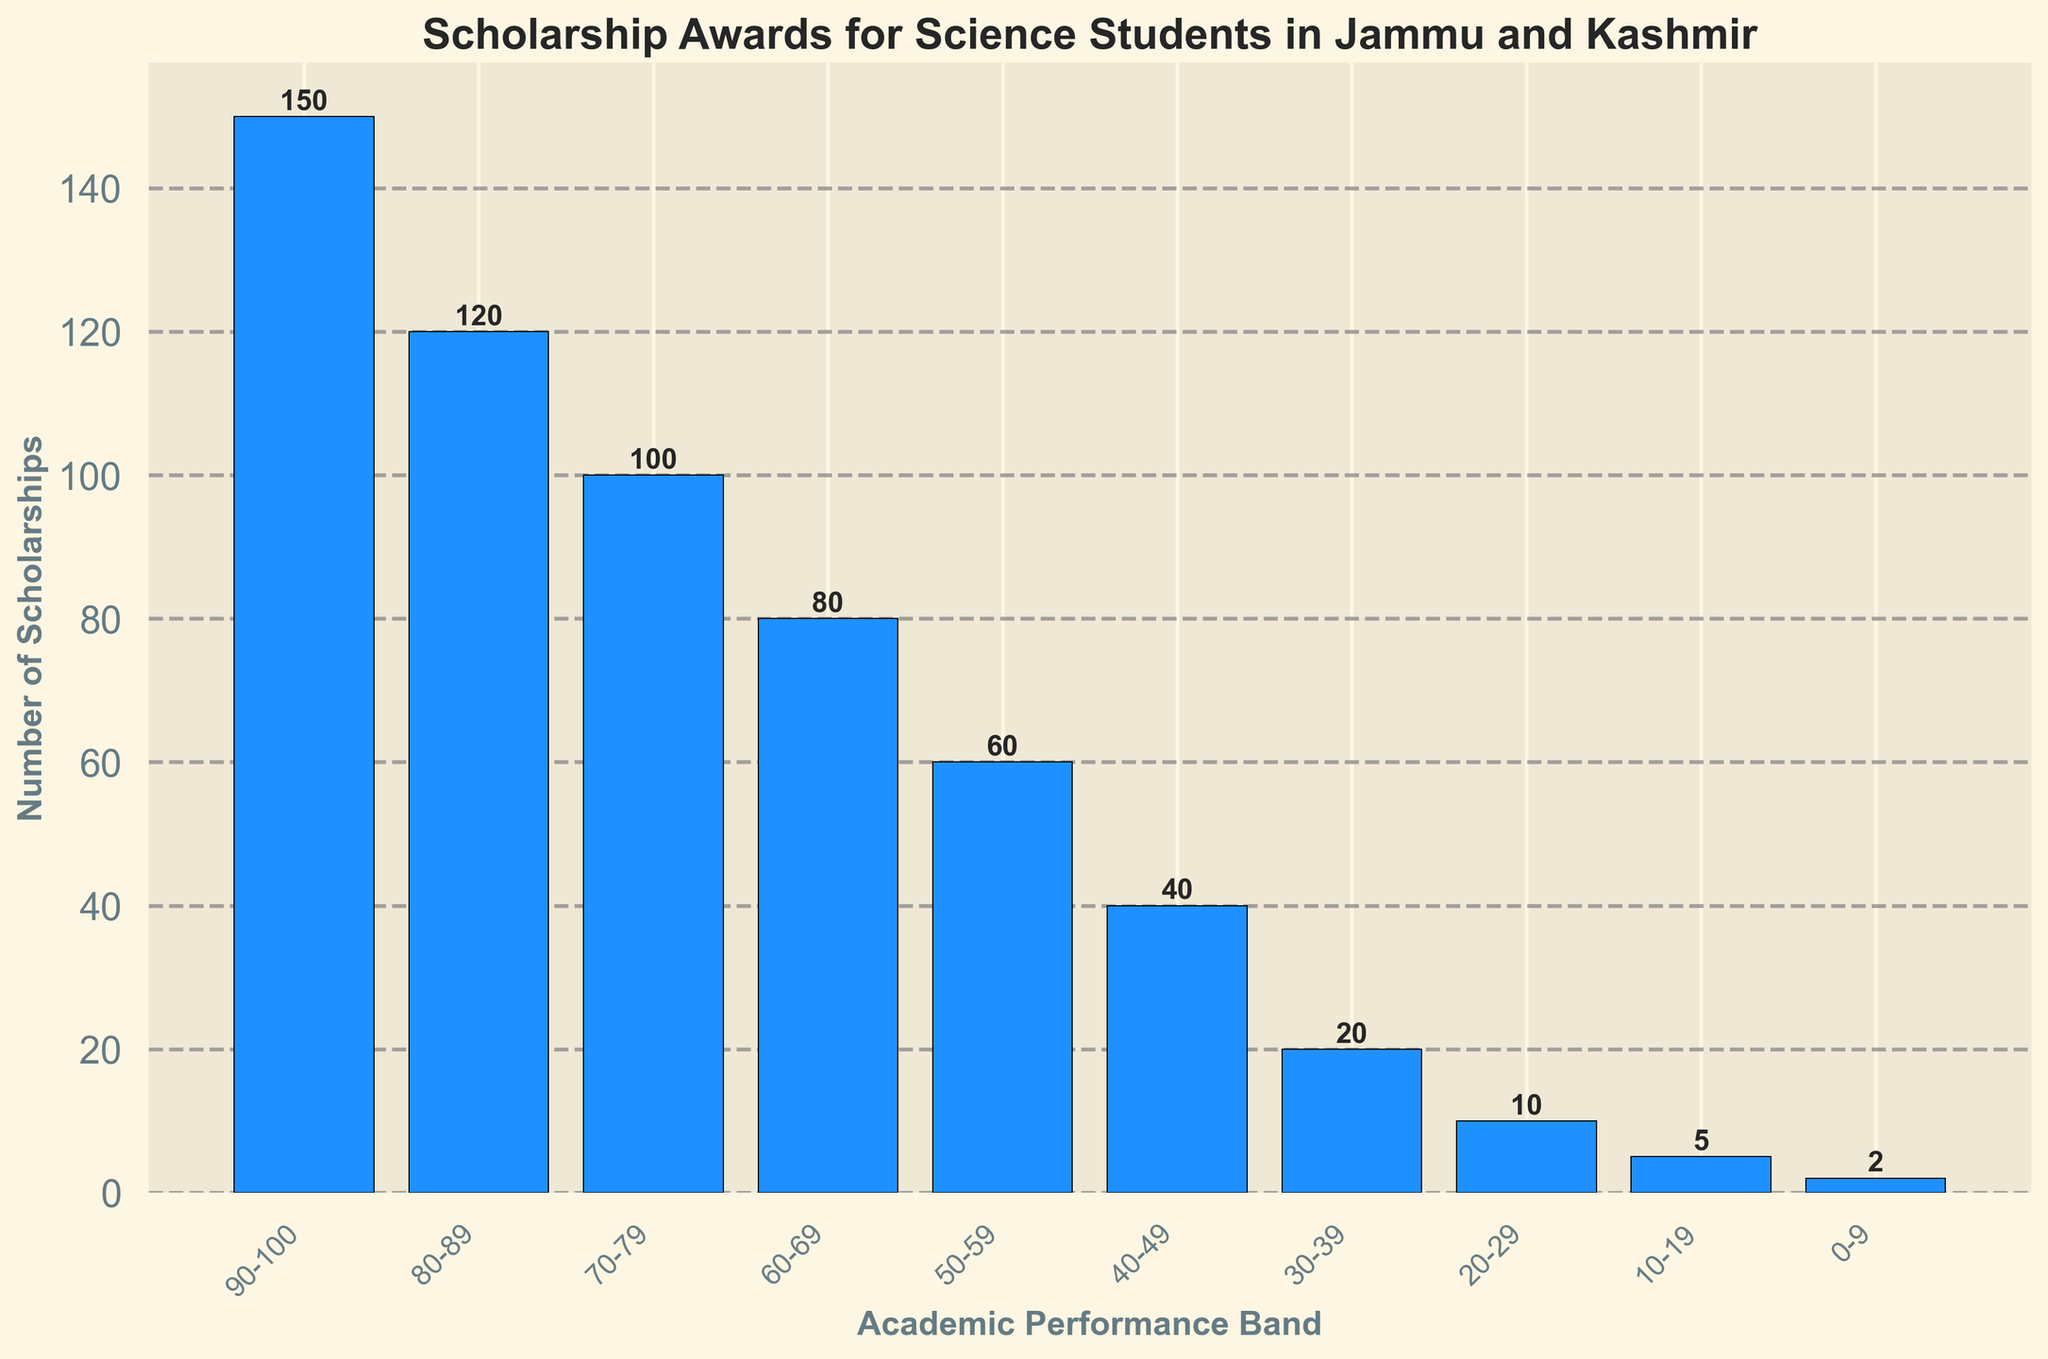What is the academic performance band that receives the highest number of scholarships? The band with the highest bar represents the greatest number of scholarships. Referring to the histogram, the 90-100 performance band shows the highest bar, indicating the highest number of scholarships.
Answer: 90-100 Which academic performance band receives the fewest scholarships? The shortest bar on the histogram indicates the fewest scholarships awarded. The 0-9 performance band has the shortest bar.
Answer: 0-9 How many more scholarships are awarded to students in the 90-100 band compared to the 70-79 band? First, identify the number of scholarships from the bars of the 90-100 and 70-79 bands, which are 150 and 100 respectively. Subtract the count of the 70-79 band from the 90-100 band: 150 - 100 = 50.
Answer: 50 What is the total number of scholarships awarded across all performance bands? Sum the heights of all bars: 150 (90-100) + 120 (80-89) + 100 (70-79) + 80 (60-69) + 60 (50-59) + 40 (40-49) + 20 (30-39) + 10 (20-29) + 5 (10-19) + 2 (0-9) = 587.
Answer: 587 What is the average number of scholarships awarded per academic performance band? There are 10 bands in total, and the sum of scholarships is 587. Calculate the average by dividing the total number of scholarships by the number of bands: 587 / 10 = 58.7.
Answer: 58.7 Which two adjacent academic performance bands combined receive the highest number of scholarships? Compare the summed values of adjacent performance bands. 90-100 and 80-89 sum up to the highest number: 150 (90-100) + 120 (80-89) = 270.
Answer: 90-100 and 80-89 Are there more scholarships awarded to students scoring between 60-79 or those scoring between 0-59? Summing the bands in each range: 60-79: 100 (70-79) + 80 (60-69) = 180. 0-59: 60 (50-59) + 40 (40-49) + 20 (30-39) + 10 (20-29) + 5 (10-19) + 2 (0-9) = 137. Compare the sums.
Answer: 60-79 What is the range (difference) in the number of scholarships awarded between the top and bottom performance bands? Subtract the number of scholarships in the 0-9 band from the 90-100 band: 150 (90-100) - 2 (0-9) = 148.
Answer: 148 